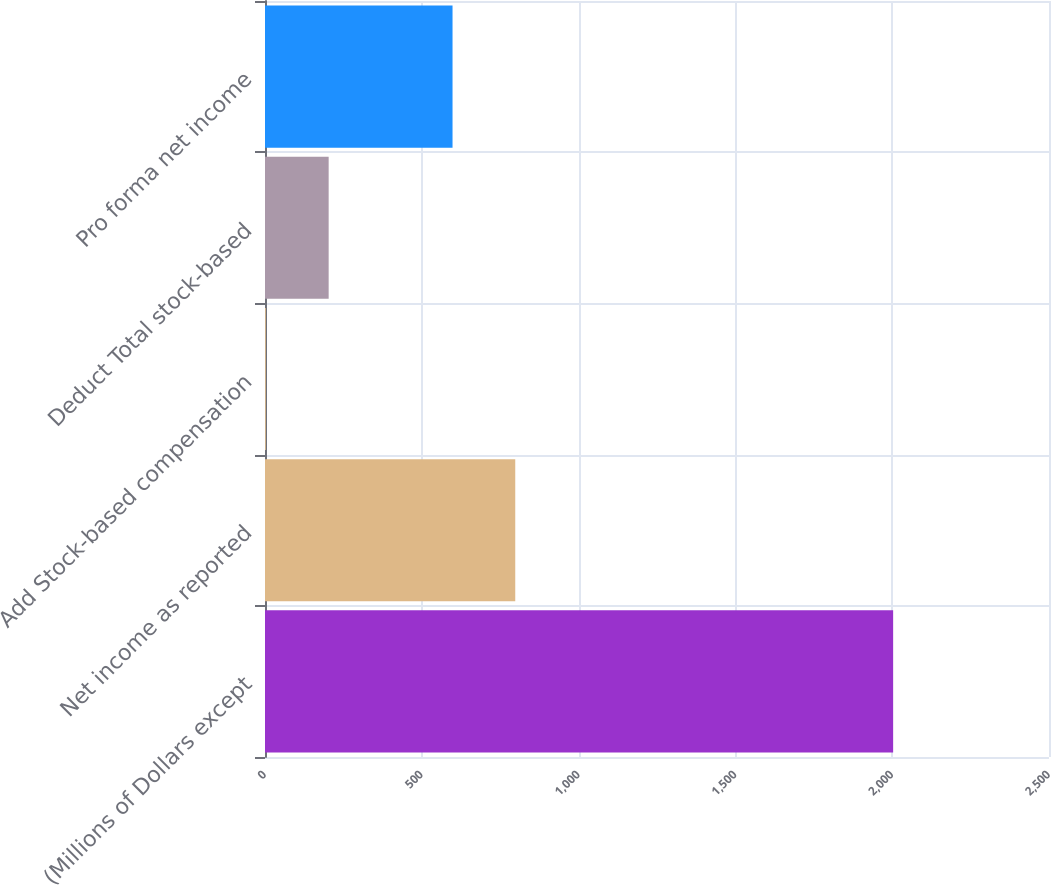Convert chart to OTSL. <chart><loc_0><loc_0><loc_500><loc_500><bar_chart><fcel>(Millions of Dollars except<fcel>Net income as reported<fcel>Add Stock-based compensation<fcel>Deduct Total stock-based<fcel>Pro forma net income<nl><fcel>2003<fcel>798<fcel>3<fcel>203<fcel>598<nl></chart> 